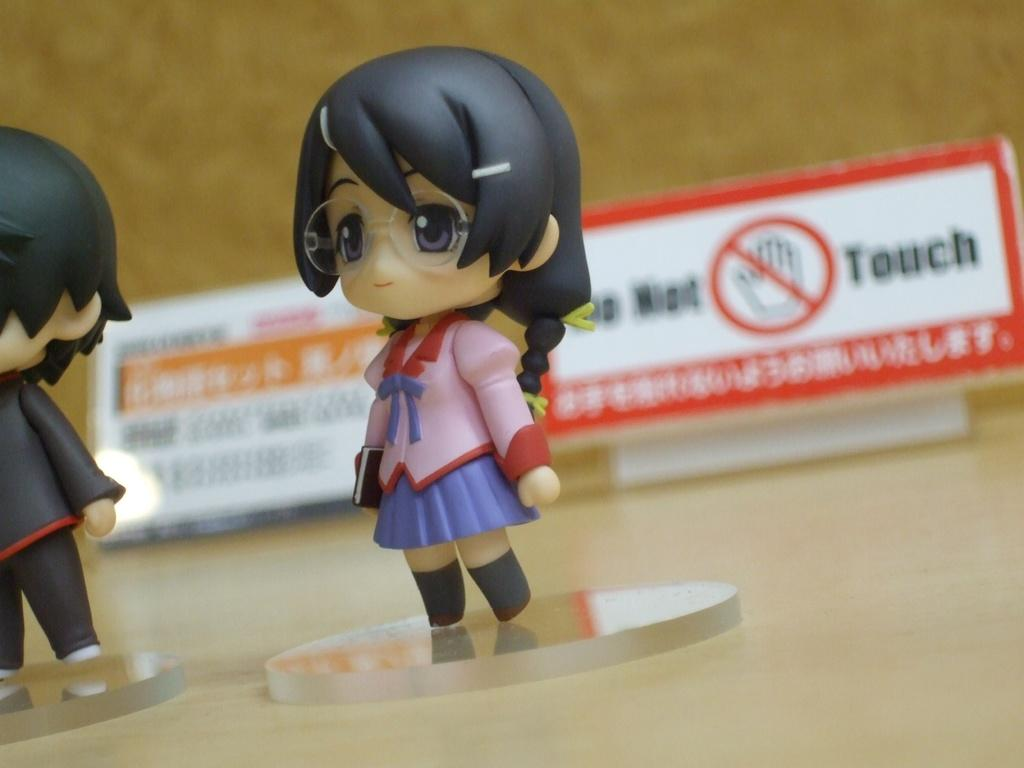What type of toys are present in the image? There are toys of a woman and a man in the image. What can be seen in the background of the image? There is a sign board and other objects visible in the background of the image. How is the background of the image depicted? The background of the image is blurred. How many lizards can be seen basking in the summer sun in the image? There are no lizards present in the image, and the image does not depict a summer scene. 